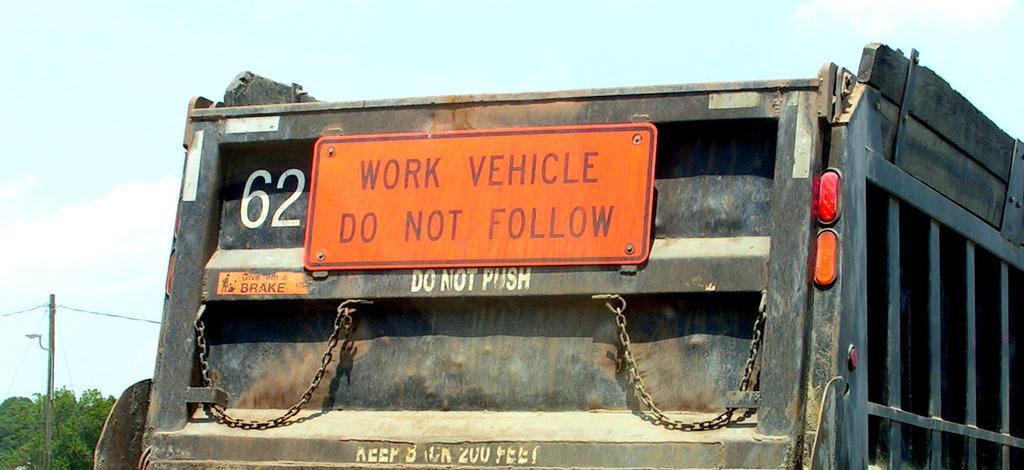In one or two sentences, can you explain what this image depicts? In this image I can see a vehicle on the road, board, trees, pole, wires and the sky. This image is taken may be during a day. 